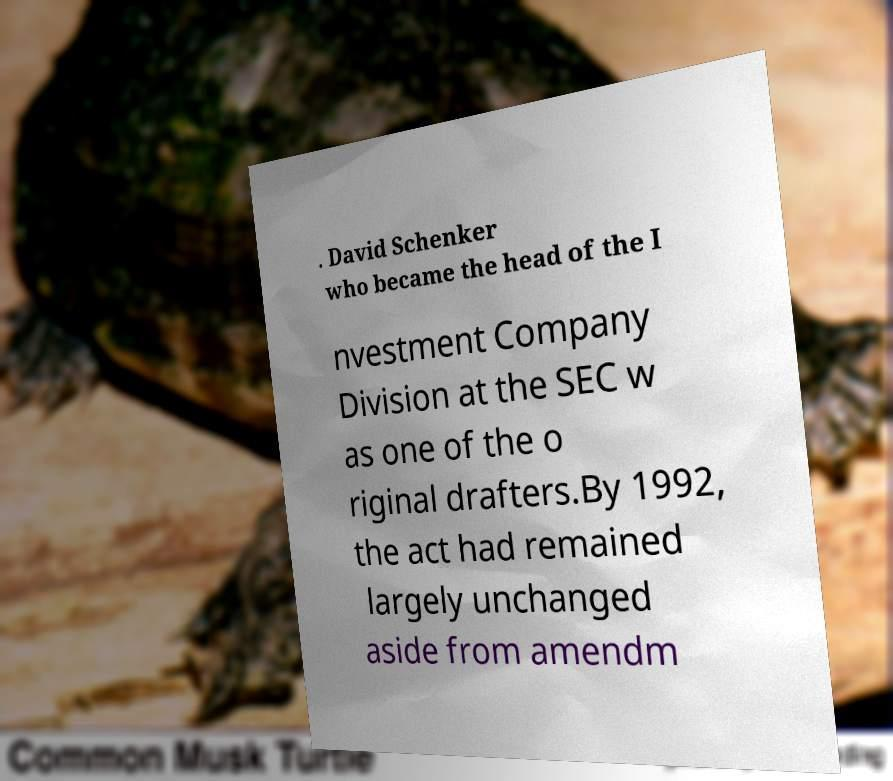For documentation purposes, I need the text within this image transcribed. Could you provide that? . David Schenker who became the head of the I nvestment Company Division at the SEC w as one of the o riginal drafters.By 1992, the act had remained largely unchanged aside from amendm 